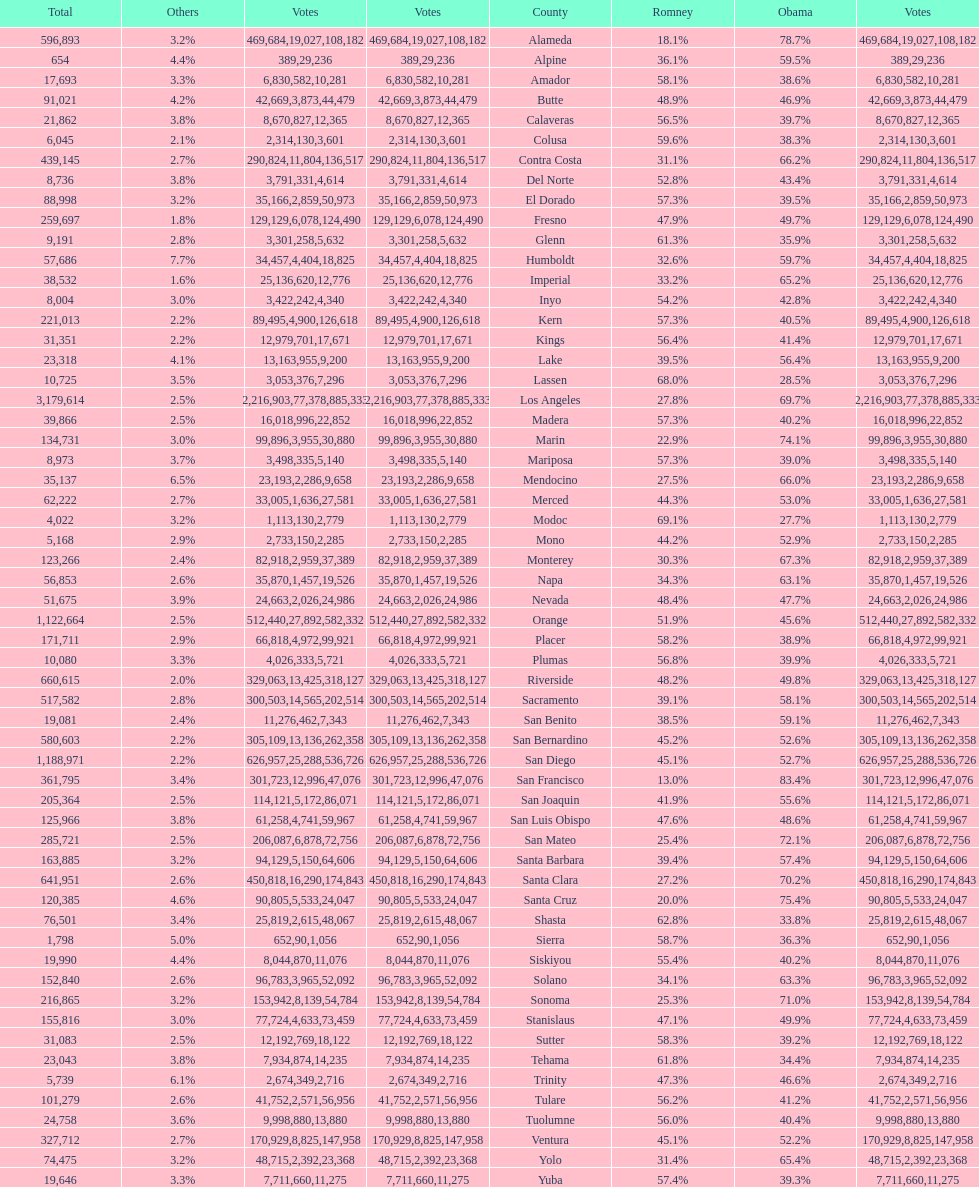Which county had the most total votes? Los Angeles. 